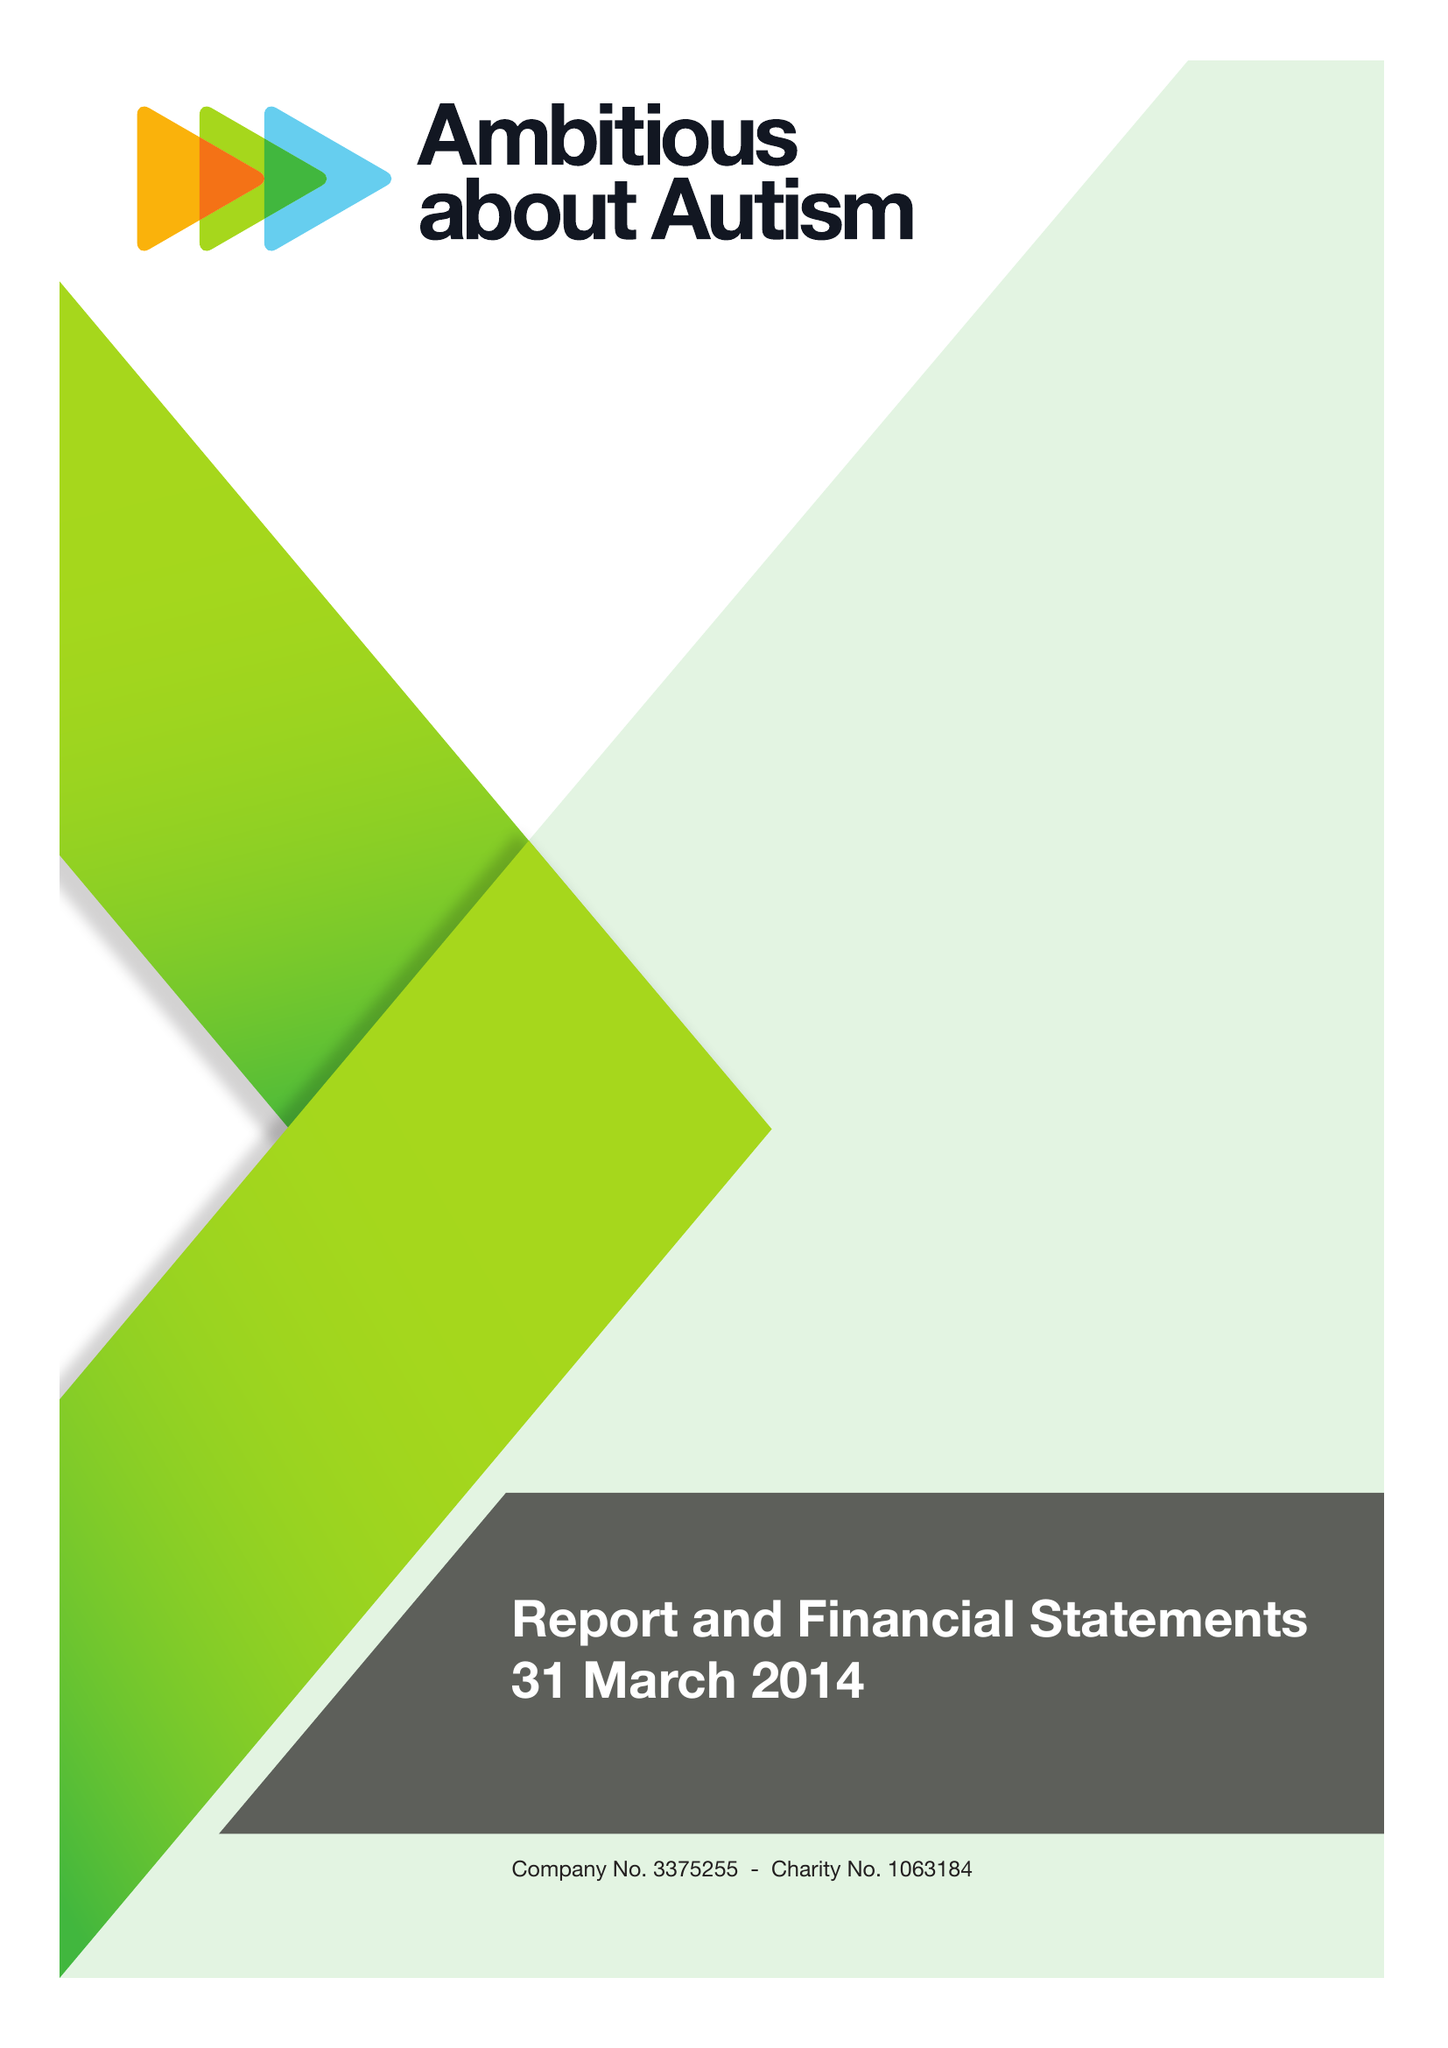What is the value for the income_annually_in_british_pounds?
Answer the question using a single word or phrase. 10000419.00 